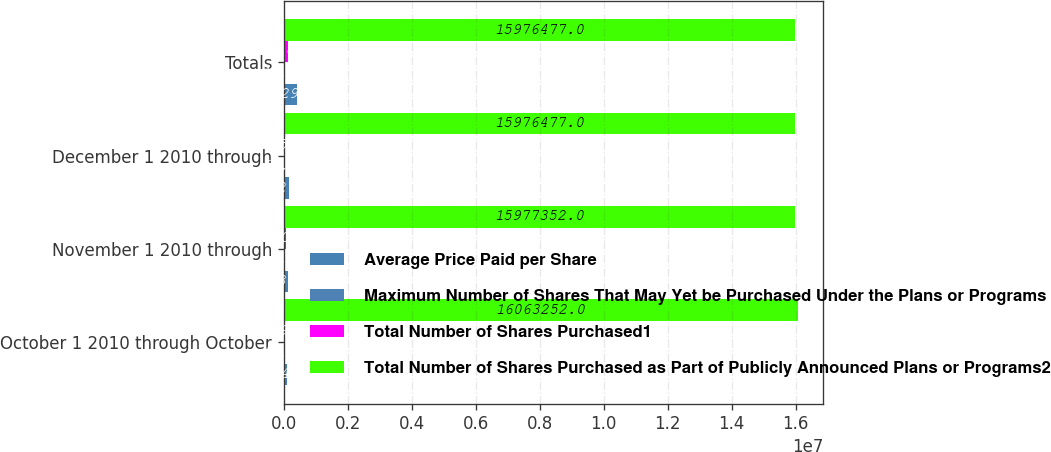Convert chart. <chart><loc_0><loc_0><loc_500><loc_500><stacked_bar_chart><ecel><fcel>October 1 2010 through October<fcel>November 1 2010 through<fcel>December 1 2010 through<fcel>Totals<nl><fcel>Average Price Paid per Share<fcel>98149<fcel>146866<fcel>173278<fcel>418293<nl><fcel>Maximum Number of Shares That May Yet be Purchased Under the Plans or Programs<fcel>46.53<fcel>47.32<fcel>50.69<fcel>48.53<nl><fcel>Total Number of Shares Purchased1<fcel>33393<fcel>85900<fcel>875<fcel>120168<nl><fcel>Total Number of Shares Purchased as Part of Publicly Announced Plans or Programs2<fcel>1.60633e+07<fcel>1.59774e+07<fcel>1.59765e+07<fcel>1.59765e+07<nl></chart> 